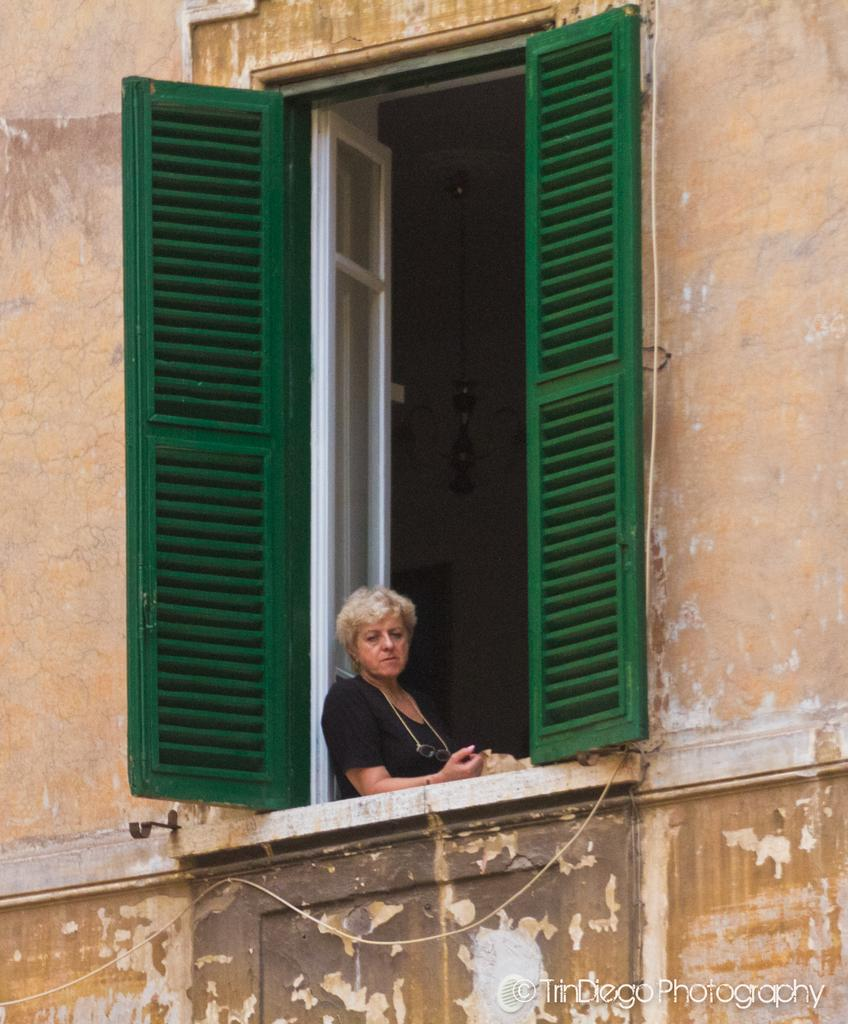Who is present in the image? There is a woman in the image. What is the woman doing in the image? The woman is standing beside a window. What is the woman's focus in the image? The woman is looking out from the window. What is the woman's profit from playing baseball in the image? There is no mention of baseball or profit in the image, as it only shows a woman standing beside a window and looking out from it. 